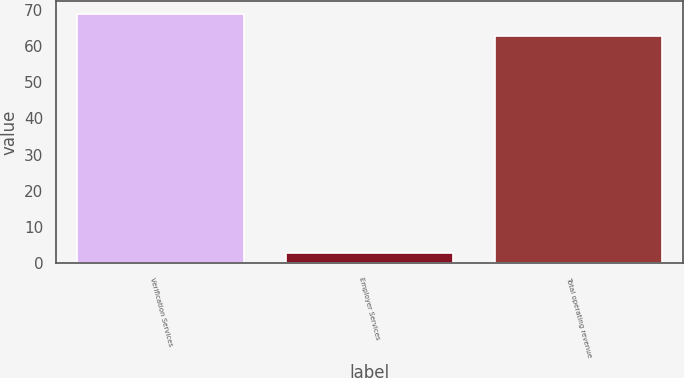Convert chart to OTSL. <chart><loc_0><loc_0><loc_500><loc_500><bar_chart><fcel>Verification Services<fcel>Employer Services<fcel>Total operating revenue<nl><fcel>68.86<fcel>2.9<fcel>62.6<nl></chart> 